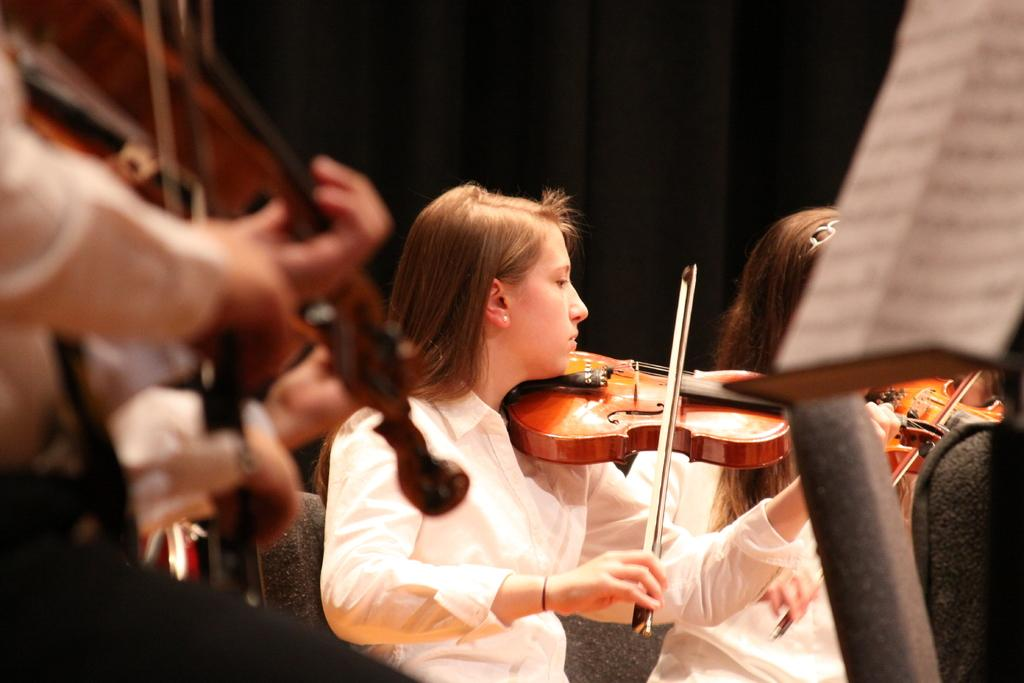What is the girl in the image doing while sitting on the chair? The girl is playing the violin. What object is the girl holding while playing the violin? The girl is holding a violin stick. Is there another person in the image? Yes, there is another girl sitting near her. What is the second girl doing in the image? The second girl is also playing the violin. What type of glove is the girl wearing while playing the violin? There is no glove mentioned or visible in the image; the girl is playing the violin without gloves. What scientific theory is being discussed by the girls in the image? There is no indication of a scientific theory being discussed in the image; the girls are focused on playing the violin. 